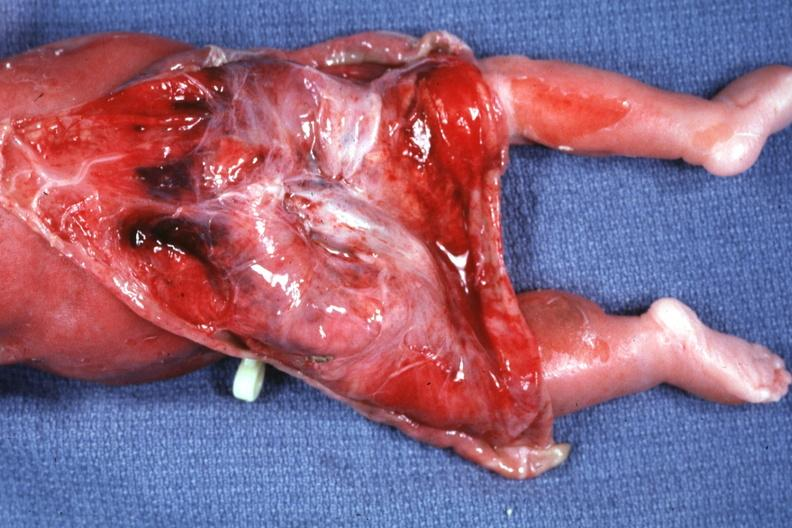s sacrococcygeal teratoma present?
Answer the question using a single word or phrase. Yes 